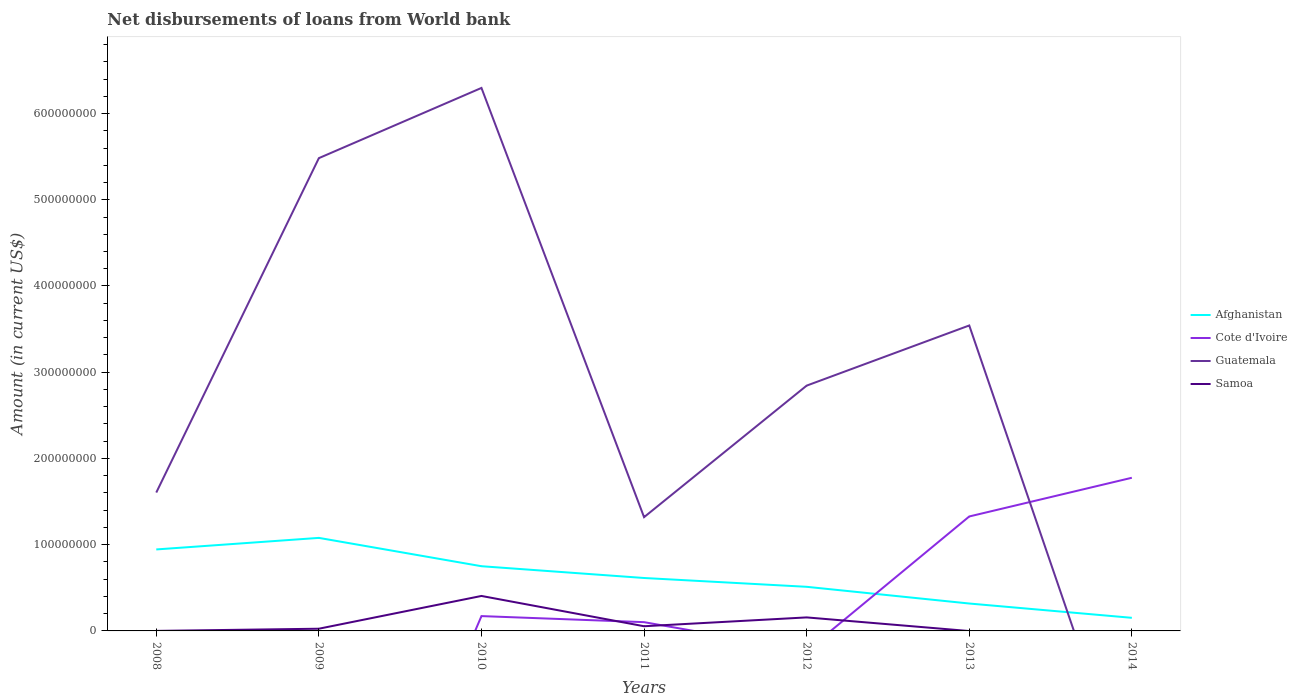How many different coloured lines are there?
Your answer should be very brief. 4. Is the number of lines equal to the number of legend labels?
Ensure brevity in your answer.  No. What is the total amount of loan disbursed from World Bank in Guatemala in the graph?
Offer a very short reply. 3.45e+08. What is the difference between the highest and the second highest amount of loan disbursed from World Bank in Afghanistan?
Your answer should be compact. 9.27e+07. What is the difference between the highest and the lowest amount of loan disbursed from World Bank in Afghanistan?
Provide a succinct answer. 3. What is the difference between two consecutive major ticks on the Y-axis?
Make the answer very short. 1.00e+08. Where does the legend appear in the graph?
Your response must be concise. Center right. How many legend labels are there?
Give a very brief answer. 4. How are the legend labels stacked?
Offer a very short reply. Vertical. What is the title of the graph?
Make the answer very short. Net disbursements of loans from World bank. What is the label or title of the X-axis?
Ensure brevity in your answer.  Years. What is the label or title of the Y-axis?
Offer a very short reply. Amount (in current US$). What is the Amount (in current US$) in Afghanistan in 2008?
Ensure brevity in your answer.  9.45e+07. What is the Amount (in current US$) of Cote d'Ivoire in 2008?
Your answer should be very brief. 0. What is the Amount (in current US$) in Guatemala in 2008?
Provide a succinct answer. 1.60e+08. What is the Amount (in current US$) in Samoa in 2008?
Keep it short and to the point. 3.60e+04. What is the Amount (in current US$) of Afghanistan in 2009?
Provide a short and direct response. 1.08e+08. What is the Amount (in current US$) of Cote d'Ivoire in 2009?
Give a very brief answer. 0. What is the Amount (in current US$) in Guatemala in 2009?
Provide a succinct answer. 5.48e+08. What is the Amount (in current US$) of Samoa in 2009?
Offer a terse response. 2.56e+06. What is the Amount (in current US$) of Afghanistan in 2010?
Your answer should be very brief. 7.50e+07. What is the Amount (in current US$) in Cote d'Ivoire in 2010?
Your answer should be compact. 1.72e+07. What is the Amount (in current US$) in Guatemala in 2010?
Offer a terse response. 6.30e+08. What is the Amount (in current US$) in Samoa in 2010?
Your answer should be compact. 4.05e+07. What is the Amount (in current US$) of Afghanistan in 2011?
Make the answer very short. 6.14e+07. What is the Amount (in current US$) in Cote d'Ivoire in 2011?
Your answer should be compact. 1.02e+07. What is the Amount (in current US$) in Guatemala in 2011?
Ensure brevity in your answer.  1.32e+08. What is the Amount (in current US$) in Samoa in 2011?
Provide a short and direct response. 5.44e+06. What is the Amount (in current US$) of Afghanistan in 2012?
Your answer should be compact. 5.12e+07. What is the Amount (in current US$) of Cote d'Ivoire in 2012?
Ensure brevity in your answer.  0. What is the Amount (in current US$) of Guatemala in 2012?
Your response must be concise. 2.84e+08. What is the Amount (in current US$) in Samoa in 2012?
Offer a very short reply. 1.57e+07. What is the Amount (in current US$) in Afghanistan in 2013?
Provide a short and direct response. 3.18e+07. What is the Amount (in current US$) in Cote d'Ivoire in 2013?
Provide a succinct answer. 1.33e+08. What is the Amount (in current US$) in Guatemala in 2013?
Your answer should be compact. 3.54e+08. What is the Amount (in current US$) in Afghanistan in 2014?
Offer a terse response. 1.52e+07. What is the Amount (in current US$) of Cote d'Ivoire in 2014?
Give a very brief answer. 1.78e+08. What is the Amount (in current US$) of Guatemala in 2014?
Your answer should be compact. 0. Across all years, what is the maximum Amount (in current US$) of Afghanistan?
Your response must be concise. 1.08e+08. Across all years, what is the maximum Amount (in current US$) of Cote d'Ivoire?
Offer a terse response. 1.78e+08. Across all years, what is the maximum Amount (in current US$) of Guatemala?
Provide a succinct answer. 6.30e+08. Across all years, what is the maximum Amount (in current US$) of Samoa?
Provide a succinct answer. 4.05e+07. Across all years, what is the minimum Amount (in current US$) of Afghanistan?
Provide a short and direct response. 1.52e+07. Across all years, what is the minimum Amount (in current US$) of Cote d'Ivoire?
Your answer should be very brief. 0. Across all years, what is the minimum Amount (in current US$) in Guatemala?
Make the answer very short. 0. What is the total Amount (in current US$) in Afghanistan in the graph?
Ensure brevity in your answer.  4.37e+08. What is the total Amount (in current US$) in Cote d'Ivoire in the graph?
Offer a terse response. 3.38e+08. What is the total Amount (in current US$) of Guatemala in the graph?
Offer a terse response. 2.11e+09. What is the total Amount (in current US$) in Samoa in the graph?
Provide a short and direct response. 6.43e+07. What is the difference between the Amount (in current US$) in Afghanistan in 2008 and that in 2009?
Provide a short and direct response. -1.34e+07. What is the difference between the Amount (in current US$) of Guatemala in 2008 and that in 2009?
Keep it short and to the point. -3.88e+08. What is the difference between the Amount (in current US$) of Samoa in 2008 and that in 2009?
Provide a short and direct response. -2.52e+06. What is the difference between the Amount (in current US$) of Afghanistan in 2008 and that in 2010?
Your answer should be very brief. 1.95e+07. What is the difference between the Amount (in current US$) of Guatemala in 2008 and that in 2010?
Provide a short and direct response. -4.69e+08. What is the difference between the Amount (in current US$) in Samoa in 2008 and that in 2010?
Your answer should be very brief. -4.05e+07. What is the difference between the Amount (in current US$) of Afghanistan in 2008 and that in 2011?
Offer a very short reply. 3.31e+07. What is the difference between the Amount (in current US$) of Guatemala in 2008 and that in 2011?
Provide a short and direct response. 2.85e+07. What is the difference between the Amount (in current US$) in Samoa in 2008 and that in 2011?
Your response must be concise. -5.40e+06. What is the difference between the Amount (in current US$) in Afghanistan in 2008 and that in 2012?
Provide a succinct answer. 4.33e+07. What is the difference between the Amount (in current US$) in Guatemala in 2008 and that in 2012?
Provide a succinct answer. -1.24e+08. What is the difference between the Amount (in current US$) of Samoa in 2008 and that in 2012?
Offer a very short reply. -1.56e+07. What is the difference between the Amount (in current US$) in Afghanistan in 2008 and that in 2013?
Give a very brief answer. 6.27e+07. What is the difference between the Amount (in current US$) of Guatemala in 2008 and that in 2013?
Keep it short and to the point. -1.94e+08. What is the difference between the Amount (in current US$) of Afghanistan in 2008 and that in 2014?
Ensure brevity in your answer.  7.93e+07. What is the difference between the Amount (in current US$) in Afghanistan in 2009 and that in 2010?
Your answer should be very brief. 3.29e+07. What is the difference between the Amount (in current US$) in Guatemala in 2009 and that in 2010?
Provide a succinct answer. -8.14e+07. What is the difference between the Amount (in current US$) in Samoa in 2009 and that in 2010?
Make the answer very short. -3.80e+07. What is the difference between the Amount (in current US$) of Afghanistan in 2009 and that in 2011?
Give a very brief answer. 4.65e+07. What is the difference between the Amount (in current US$) in Guatemala in 2009 and that in 2011?
Your answer should be compact. 4.16e+08. What is the difference between the Amount (in current US$) in Samoa in 2009 and that in 2011?
Give a very brief answer. -2.88e+06. What is the difference between the Amount (in current US$) in Afghanistan in 2009 and that in 2012?
Provide a short and direct response. 5.67e+07. What is the difference between the Amount (in current US$) in Guatemala in 2009 and that in 2012?
Provide a short and direct response. 2.64e+08. What is the difference between the Amount (in current US$) of Samoa in 2009 and that in 2012?
Your answer should be very brief. -1.31e+07. What is the difference between the Amount (in current US$) of Afghanistan in 2009 and that in 2013?
Give a very brief answer. 7.61e+07. What is the difference between the Amount (in current US$) in Guatemala in 2009 and that in 2013?
Ensure brevity in your answer.  1.94e+08. What is the difference between the Amount (in current US$) of Afghanistan in 2009 and that in 2014?
Your response must be concise. 9.27e+07. What is the difference between the Amount (in current US$) of Afghanistan in 2010 and that in 2011?
Ensure brevity in your answer.  1.37e+07. What is the difference between the Amount (in current US$) in Cote d'Ivoire in 2010 and that in 2011?
Your answer should be very brief. 7.03e+06. What is the difference between the Amount (in current US$) in Guatemala in 2010 and that in 2011?
Keep it short and to the point. 4.98e+08. What is the difference between the Amount (in current US$) in Samoa in 2010 and that in 2011?
Provide a short and direct response. 3.51e+07. What is the difference between the Amount (in current US$) of Afghanistan in 2010 and that in 2012?
Provide a short and direct response. 2.39e+07. What is the difference between the Amount (in current US$) of Guatemala in 2010 and that in 2012?
Your answer should be compact. 3.45e+08. What is the difference between the Amount (in current US$) in Samoa in 2010 and that in 2012?
Your answer should be compact. 2.49e+07. What is the difference between the Amount (in current US$) of Afghanistan in 2010 and that in 2013?
Make the answer very short. 4.33e+07. What is the difference between the Amount (in current US$) in Cote d'Ivoire in 2010 and that in 2013?
Ensure brevity in your answer.  -1.16e+08. What is the difference between the Amount (in current US$) of Guatemala in 2010 and that in 2013?
Your response must be concise. 2.75e+08. What is the difference between the Amount (in current US$) in Afghanistan in 2010 and that in 2014?
Your answer should be compact. 5.98e+07. What is the difference between the Amount (in current US$) in Cote d'Ivoire in 2010 and that in 2014?
Provide a succinct answer. -1.60e+08. What is the difference between the Amount (in current US$) of Afghanistan in 2011 and that in 2012?
Offer a terse response. 1.02e+07. What is the difference between the Amount (in current US$) in Guatemala in 2011 and that in 2012?
Make the answer very short. -1.53e+08. What is the difference between the Amount (in current US$) in Samoa in 2011 and that in 2012?
Your answer should be very brief. -1.02e+07. What is the difference between the Amount (in current US$) in Afghanistan in 2011 and that in 2013?
Ensure brevity in your answer.  2.96e+07. What is the difference between the Amount (in current US$) of Cote d'Ivoire in 2011 and that in 2013?
Your answer should be compact. -1.23e+08. What is the difference between the Amount (in current US$) in Guatemala in 2011 and that in 2013?
Make the answer very short. -2.22e+08. What is the difference between the Amount (in current US$) of Afghanistan in 2011 and that in 2014?
Your answer should be very brief. 4.62e+07. What is the difference between the Amount (in current US$) in Cote d'Ivoire in 2011 and that in 2014?
Give a very brief answer. -1.67e+08. What is the difference between the Amount (in current US$) of Afghanistan in 2012 and that in 2013?
Your answer should be very brief. 1.94e+07. What is the difference between the Amount (in current US$) of Guatemala in 2012 and that in 2013?
Offer a terse response. -6.98e+07. What is the difference between the Amount (in current US$) of Afghanistan in 2012 and that in 2014?
Ensure brevity in your answer.  3.60e+07. What is the difference between the Amount (in current US$) of Afghanistan in 2013 and that in 2014?
Give a very brief answer. 1.66e+07. What is the difference between the Amount (in current US$) in Cote d'Ivoire in 2013 and that in 2014?
Your answer should be very brief. -4.49e+07. What is the difference between the Amount (in current US$) of Afghanistan in 2008 and the Amount (in current US$) of Guatemala in 2009?
Your response must be concise. -4.54e+08. What is the difference between the Amount (in current US$) in Afghanistan in 2008 and the Amount (in current US$) in Samoa in 2009?
Offer a terse response. 9.19e+07. What is the difference between the Amount (in current US$) of Guatemala in 2008 and the Amount (in current US$) of Samoa in 2009?
Provide a succinct answer. 1.58e+08. What is the difference between the Amount (in current US$) of Afghanistan in 2008 and the Amount (in current US$) of Cote d'Ivoire in 2010?
Keep it short and to the point. 7.73e+07. What is the difference between the Amount (in current US$) of Afghanistan in 2008 and the Amount (in current US$) of Guatemala in 2010?
Offer a very short reply. -5.35e+08. What is the difference between the Amount (in current US$) of Afghanistan in 2008 and the Amount (in current US$) of Samoa in 2010?
Provide a succinct answer. 5.40e+07. What is the difference between the Amount (in current US$) of Guatemala in 2008 and the Amount (in current US$) of Samoa in 2010?
Keep it short and to the point. 1.20e+08. What is the difference between the Amount (in current US$) of Afghanistan in 2008 and the Amount (in current US$) of Cote d'Ivoire in 2011?
Your response must be concise. 8.43e+07. What is the difference between the Amount (in current US$) in Afghanistan in 2008 and the Amount (in current US$) in Guatemala in 2011?
Your answer should be very brief. -3.74e+07. What is the difference between the Amount (in current US$) in Afghanistan in 2008 and the Amount (in current US$) in Samoa in 2011?
Keep it short and to the point. 8.91e+07. What is the difference between the Amount (in current US$) of Guatemala in 2008 and the Amount (in current US$) of Samoa in 2011?
Your answer should be compact. 1.55e+08. What is the difference between the Amount (in current US$) of Afghanistan in 2008 and the Amount (in current US$) of Guatemala in 2012?
Your answer should be compact. -1.90e+08. What is the difference between the Amount (in current US$) in Afghanistan in 2008 and the Amount (in current US$) in Samoa in 2012?
Ensure brevity in your answer.  7.88e+07. What is the difference between the Amount (in current US$) of Guatemala in 2008 and the Amount (in current US$) of Samoa in 2012?
Provide a short and direct response. 1.45e+08. What is the difference between the Amount (in current US$) of Afghanistan in 2008 and the Amount (in current US$) of Cote d'Ivoire in 2013?
Provide a short and direct response. -3.82e+07. What is the difference between the Amount (in current US$) of Afghanistan in 2008 and the Amount (in current US$) of Guatemala in 2013?
Give a very brief answer. -2.60e+08. What is the difference between the Amount (in current US$) of Afghanistan in 2008 and the Amount (in current US$) of Cote d'Ivoire in 2014?
Ensure brevity in your answer.  -8.31e+07. What is the difference between the Amount (in current US$) of Afghanistan in 2009 and the Amount (in current US$) of Cote d'Ivoire in 2010?
Your answer should be very brief. 9.07e+07. What is the difference between the Amount (in current US$) of Afghanistan in 2009 and the Amount (in current US$) of Guatemala in 2010?
Give a very brief answer. -5.22e+08. What is the difference between the Amount (in current US$) in Afghanistan in 2009 and the Amount (in current US$) in Samoa in 2010?
Offer a very short reply. 6.73e+07. What is the difference between the Amount (in current US$) of Guatemala in 2009 and the Amount (in current US$) of Samoa in 2010?
Your answer should be compact. 5.08e+08. What is the difference between the Amount (in current US$) in Afghanistan in 2009 and the Amount (in current US$) in Cote d'Ivoire in 2011?
Give a very brief answer. 9.77e+07. What is the difference between the Amount (in current US$) in Afghanistan in 2009 and the Amount (in current US$) in Guatemala in 2011?
Make the answer very short. -2.40e+07. What is the difference between the Amount (in current US$) of Afghanistan in 2009 and the Amount (in current US$) of Samoa in 2011?
Your response must be concise. 1.02e+08. What is the difference between the Amount (in current US$) of Guatemala in 2009 and the Amount (in current US$) of Samoa in 2011?
Offer a very short reply. 5.43e+08. What is the difference between the Amount (in current US$) in Afghanistan in 2009 and the Amount (in current US$) in Guatemala in 2012?
Your answer should be very brief. -1.77e+08. What is the difference between the Amount (in current US$) in Afghanistan in 2009 and the Amount (in current US$) in Samoa in 2012?
Your answer should be very brief. 9.22e+07. What is the difference between the Amount (in current US$) in Guatemala in 2009 and the Amount (in current US$) in Samoa in 2012?
Your answer should be compact. 5.33e+08. What is the difference between the Amount (in current US$) of Afghanistan in 2009 and the Amount (in current US$) of Cote d'Ivoire in 2013?
Give a very brief answer. -2.48e+07. What is the difference between the Amount (in current US$) of Afghanistan in 2009 and the Amount (in current US$) of Guatemala in 2013?
Provide a succinct answer. -2.46e+08. What is the difference between the Amount (in current US$) in Afghanistan in 2009 and the Amount (in current US$) in Cote d'Ivoire in 2014?
Your answer should be very brief. -6.97e+07. What is the difference between the Amount (in current US$) in Afghanistan in 2010 and the Amount (in current US$) in Cote d'Ivoire in 2011?
Make the answer very short. 6.49e+07. What is the difference between the Amount (in current US$) of Afghanistan in 2010 and the Amount (in current US$) of Guatemala in 2011?
Provide a short and direct response. -5.69e+07. What is the difference between the Amount (in current US$) in Afghanistan in 2010 and the Amount (in current US$) in Samoa in 2011?
Give a very brief answer. 6.96e+07. What is the difference between the Amount (in current US$) in Cote d'Ivoire in 2010 and the Amount (in current US$) in Guatemala in 2011?
Keep it short and to the point. -1.15e+08. What is the difference between the Amount (in current US$) in Cote d'Ivoire in 2010 and the Amount (in current US$) in Samoa in 2011?
Give a very brief answer. 1.18e+07. What is the difference between the Amount (in current US$) in Guatemala in 2010 and the Amount (in current US$) in Samoa in 2011?
Give a very brief answer. 6.24e+08. What is the difference between the Amount (in current US$) of Afghanistan in 2010 and the Amount (in current US$) of Guatemala in 2012?
Offer a terse response. -2.09e+08. What is the difference between the Amount (in current US$) of Afghanistan in 2010 and the Amount (in current US$) of Samoa in 2012?
Give a very brief answer. 5.94e+07. What is the difference between the Amount (in current US$) of Cote d'Ivoire in 2010 and the Amount (in current US$) of Guatemala in 2012?
Make the answer very short. -2.67e+08. What is the difference between the Amount (in current US$) in Cote d'Ivoire in 2010 and the Amount (in current US$) in Samoa in 2012?
Provide a short and direct response. 1.53e+06. What is the difference between the Amount (in current US$) in Guatemala in 2010 and the Amount (in current US$) in Samoa in 2012?
Provide a short and direct response. 6.14e+08. What is the difference between the Amount (in current US$) in Afghanistan in 2010 and the Amount (in current US$) in Cote d'Ivoire in 2013?
Offer a terse response. -5.77e+07. What is the difference between the Amount (in current US$) of Afghanistan in 2010 and the Amount (in current US$) of Guatemala in 2013?
Provide a succinct answer. -2.79e+08. What is the difference between the Amount (in current US$) in Cote d'Ivoire in 2010 and the Amount (in current US$) in Guatemala in 2013?
Your answer should be compact. -3.37e+08. What is the difference between the Amount (in current US$) in Afghanistan in 2010 and the Amount (in current US$) in Cote d'Ivoire in 2014?
Your response must be concise. -1.03e+08. What is the difference between the Amount (in current US$) in Afghanistan in 2011 and the Amount (in current US$) in Guatemala in 2012?
Offer a very short reply. -2.23e+08. What is the difference between the Amount (in current US$) of Afghanistan in 2011 and the Amount (in current US$) of Samoa in 2012?
Offer a very short reply. 4.57e+07. What is the difference between the Amount (in current US$) in Cote d'Ivoire in 2011 and the Amount (in current US$) in Guatemala in 2012?
Give a very brief answer. -2.74e+08. What is the difference between the Amount (in current US$) of Cote d'Ivoire in 2011 and the Amount (in current US$) of Samoa in 2012?
Ensure brevity in your answer.  -5.50e+06. What is the difference between the Amount (in current US$) of Guatemala in 2011 and the Amount (in current US$) of Samoa in 2012?
Your response must be concise. 1.16e+08. What is the difference between the Amount (in current US$) of Afghanistan in 2011 and the Amount (in current US$) of Cote d'Ivoire in 2013?
Give a very brief answer. -7.14e+07. What is the difference between the Amount (in current US$) of Afghanistan in 2011 and the Amount (in current US$) of Guatemala in 2013?
Provide a short and direct response. -2.93e+08. What is the difference between the Amount (in current US$) in Cote d'Ivoire in 2011 and the Amount (in current US$) in Guatemala in 2013?
Provide a short and direct response. -3.44e+08. What is the difference between the Amount (in current US$) in Afghanistan in 2011 and the Amount (in current US$) in Cote d'Ivoire in 2014?
Keep it short and to the point. -1.16e+08. What is the difference between the Amount (in current US$) of Afghanistan in 2012 and the Amount (in current US$) of Cote d'Ivoire in 2013?
Offer a terse response. -8.16e+07. What is the difference between the Amount (in current US$) of Afghanistan in 2012 and the Amount (in current US$) of Guatemala in 2013?
Provide a short and direct response. -3.03e+08. What is the difference between the Amount (in current US$) of Afghanistan in 2012 and the Amount (in current US$) of Cote d'Ivoire in 2014?
Offer a very short reply. -1.26e+08. What is the difference between the Amount (in current US$) in Afghanistan in 2013 and the Amount (in current US$) in Cote d'Ivoire in 2014?
Ensure brevity in your answer.  -1.46e+08. What is the average Amount (in current US$) in Afghanistan per year?
Ensure brevity in your answer.  6.24e+07. What is the average Amount (in current US$) in Cote d'Ivoire per year?
Your response must be concise. 4.82e+07. What is the average Amount (in current US$) in Guatemala per year?
Make the answer very short. 3.01e+08. What is the average Amount (in current US$) of Samoa per year?
Keep it short and to the point. 9.18e+06. In the year 2008, what is the difference between the Amount (in current US$) in Afghanistan and Amount (in current US$) in Guatemala?
Give a very brief answer. -6.60e+07. In the year 2008, what is the difference between the Amount (in current US$) in Afghanistan and Amount (in current US$) in Samoa?
Offer a terse response. 9.45e+07. In the year 2008, what is the difference between the Amount (in current US$) of Guatemala and Amount (in current US$) of Samoa?
Your response must be concise. 1.60e+08. In the year 2009, what is the difference between the Amount (in current US$) in Afghanistan and Amount (in current US$) in Guatemala?
Provide a succinct answer. -4.40e+08. In the year 2009, what is the difference between the Amount (in current US$) of Afghanistan and Amount (in current US$) of Samoa?
Your answer should be compact. 1.05e+08. In the year 2009, what is the difference between the Amount (in current US$) of Guatemala and Amount (in current US$) of Samoa?
Offer a very short reply. 5.46e+08. In the year 2010, what is the difference between the Amount (in current US$) of Afghanistan and Amount (in current US$) of Cote d'Ivoire?
Offer a very short reply. 5.78e+07. In the year 2010, what is the difference between the Amount (in current US$) in Afghanistan and Amount (in current US$) in Guatemala?
Make the answer very short. -5.55e+08. In the year 2010, what is the difference between the Amount (in current US$) in Afghanistan and Amount (in current US$) in Samoa?
Keep it short and to the point. 3.45e+07. In the year 2010, what is the difference between the Amount (in current US$) in Cote d'Ivoire and Amount (in current US$) in Guatemala?
Offer a terse response. -6.12e+08. In the year 2010, what is the difference between the Amount (in current US$) of Cote d'Ivoire and Amount (in current US$) of Samoa?
Your answer should be compact. -2.33e+07. In the year 2010, what is the difference between the Amount (in current US$) of Guatemala and Amount (in current US$) of Samoa?
Your answer should be compact. 5.89e+08. In the year 2011, what is the difference between the Amount (in current US$) of Afghanistan and Amount (in current US$) of Cote d'Ivoire?
Offer a very short reply. 5.12e+07. In the year 2011, what is the difference between the Amount (in current US$) of Afghanistan and Amount (in current US$) of Guatemala?
Make the answer very short. -7.05e+07. In the year 2011, what is the difference between the Amount (in current US$) in Afghanistan and Amount (in current US$) in Samoa?
Your answer should be compact. 5.59e+07. In the year 2011, what is the difference between the Amount (in current US$) of Cote d'Ivoire and Amount (in current US$) of Guatemala?
Your response must be concise. -1.22e+08. In the year 2011, what is the difference between the Amount (in current US$) in Cote d'Ivoire and Amount (in current US$) in Samoa?
Give a very brief answer. 4.73e+06. In the year 2011, what is the difference between the Amount (in current US$) in Guatemala and Amount (in current US$) in Samoa?
Ensure brevity in your answer.  1.26e+08. In the year 2012, what is the difference between the Amount (in current US$) of Afghanistan and Amount (in current US$) of Guatemala?
Give a very brief answer. -2.33e+08. In the year 2012, what is the difference between the Amount (in current US$) of Afghanistan and Amount (in current US$) of Samoa?
Give a very brief answer. 3.55e+07. In the year 2012, what is the difference between the Amount (in current US$) in Guatemala and Amount (in current US$) in Samoa?
Provide a short and direct response. 2.69e+08. In the year 2013, what is the difference between the Amount (in current US$) in Afghanistan and Amount (in current US$) in Cote d'Ivoire?
Keep it short and to the point. -1.01e+08. In the year 2013, what is the difference between the Amount (in current US$) of Afghanistan and Amount (in current US$) of Guatemala?
Offer a terse response. -3.22e+08. In the year 2013, what is the difference between the Amount (in current US$) of Cote d'Ivoire and Amount (in current US$) of Guatemala?
Give a very brief answer. -2.21e+08. In the year 2014, what is the difference between the Amount (in current US$) in Afghanistan and Amount (in current US$) in Cote d'Ivoire?
Offer a terse response. -1.62e+08. What is the ratio of the Amount (in current US$) in Afghanistan in 2008 to that in 2009?
Provide a succinct answer. 0.88. What is the ratio of the Amount (in current US$) in Guatemala in 2008 to that in 2009?
Make the answer very short. 0.29. What is the ratio of the Amount (in current US$) of Samoa in 2008 to that in 2009?
Provide a short and direct response. 0.01. What is the ratio of the Amount (in current US$) in Afghanistan in 2008 to that in 2010?
Keep it short and to the point. 1.26. What is the ratio of the Amount (in current US$) of Guatemala in 2008 to that in 2010?
Offer a terse response. 0.25. What is the ratio of the Amount (in current US$) in Samoa in 2008 to that in 2010?
Your answer should be very brief. 0. What is the ratio of the Amount (in current US$) of Afghanistan in 2008 to that in 2011?
Your answer should be compact. 1.54. What is the ratio of the Amount (in current US$) in Guatemala in 2008 to that in 2011?
Ensure brevity in your answer.  1.22. What is the ratio of the Amount (in current US$) of Samoa in 2008 to that in 2011?
Your answer should be very brief. 0.01. What is the ratio of the Amount (in current US$) of Afghanistan in 2008 to that in 2012?
Keep it short and to the point. 1.85. What is the ratio of the Amount (in current US$) in Guatemala in 2008 to that in 2012?
Your answer should be very brief. 0.56. What is the ratio of the Amount (in current US$) in Samoa in 2008 to that in 2012?
Provide a short and direct response. 0. What is the ratio of the Amount (in current US$) in Afghanistan in 2008 to that in 2013?
Offer a very short reply. 2.97. What is the ratio of the Amount (in current US$) of Guatemala in 2008 to that in 2013?
Offer a very short reply. 0.45. What is the ratio of the Amount (in current US$) in Afghanistan in 2008 to that in 2014?
Your answer should be very brief. 6.22. What is the ratio of the Amount (in current US$) of Afghanistan in 2009 to that in 2010?
Your answer should be compact. 1.44. What is the ratio of the Amount (in current US$) of Guatemala in 2009 to that in 2010?
Offer a very short reply. 0.87. What is the ratio of the Amount (in current US$) in Samoa in 2009 to that in 2010?
Give a very brief answer. 0.06. What is the ratio of the Amount (in current US$) in Afghanistan in 2009 to that in 2011?
Keep it short and to the point. 1.76. What is the ratio of the Amount (in current US$) in Guatemala in 2009 to that in 2011?
Make the answer very short. 4.16. What is the ratio of the Amount (in current US$) of Samoa in 2009 to that in 2011?
Ensure brevity in your answer.  0.47. What is the ratio of the Amount (in current US$) in Afghanistan in 2009 to that in 2012?
Ensure brevity in your answer.  2.11. What is the ratio of the Amount (in current US$) in Guatemala in 2009 to that in 2012?
Give a very brief answer. 1.93. What is the ratio of the Amount (in current US$) in Samoa in 2009 to that in 2012?
Your response must be concise. 0.16. What is the ratio of the Amount (in current US$) of Afghanistan in 2009 to that in 2013?
Keep it short and to the point. 3.39. What is the ratio of the Amount (in current US$) in Guatemala in 2009 to that in 2013?
Your response must be concise. 1.55. What is the ratio of the Amount (in current US$) of Afghanistan in 2009 to that in 2014?
Your answer should be compact. 7.1. What is the ratio of the Amount (in current US$) in Afghanistan in 2010 to that in 2011?
Provide a short and direct response. 1.22. What is the ratio of the Amount (in current US$) in Cote d'Ivoire in 2010 to that in 2011?
Provide a short and direct response. 1.69. What is the ratio of the Amount (in current US$) in Guatemala in 2010 to that in 2011?
Provide a short and direct response. 4.77. What is the ratio of the Amount (in current US$) of Samoa in 2010 to that in 2011?
Offer a terse response. 7.45. What is the ratio of the Amount (in current US$) in Afghanistan in 2010 to that in 2012?
Provide a succinct answer. 1.47. What is the ratio of the Amount (in current US$) of Guatemala in 2010 to that in 2012?
Offer a very short reply. 2.21. What is the ratio of the Amount (in current US$) in Samoa in 2010 to that in 2012?
Provide a short and direct response. 2.59. What is the ratio of the Amount (in current US$) of Afghanistan in 2010 to that in 2013?
Give a very brief answer. 2.36. What is the ratio of the Amount (in current US$) in Cote d'Ivoire in 2010 to that in 2013?
Make the answer very short. 0.13. What is the ratio of the Amount (in current US$) of Guatemala in 2010 to that in 2013?
Offer a terse response. 1.78. What is the ratio of the Amount (in current US$) in Afghanistan in 2010 to that in 2014?
Offer a very short reply. 4.94. What is the ratio of the Amount (in current US$) of Cote d'Ivoire in 2010 to that in 2014?
Keep it short and to the point. 0.1. What is the ratio of the Amount (in current US$) of Afghanistan in 2011 to that in 2012?
Give a very brief answer. 1.2. What is the ratio of the Amount (in current US$) in Guatemala in 2011 to that in 2012?
Keep it short and to the point. 0.46. What is the ratio of the Amount (in current US$) in Samoa in 2011 to that in 2012?
Keep it short and to the point. 0.35. What is the ratio of the Amount (in current US$) in Afghanistan in 2011 to that in 2013?
Offer a very short reply. 1.93. What is the ratio of the Amount (in current US$) in Cote d'Ivoire in 2011 to that in 2013?
Ensure brevity in your answer.  0.08. What is the ratio of the Amount (in current US$) in Guatemala in 2011 to that in 2013?
Provide a succinct answer. 0.37. What is the ratio of the Amount (in current US$) in Afghanistan in 2011 to that in 2014?
Provide a succinct answer. 4.04. What is the ratio of the Amount (in current US$) of Cote d'Ivoire in 2011 to that in 2014?
Offer a terse response. 0.06. What is the ratio of the Amount (in current US$) of Afghanistan in 2012 to that in 2013?
Keep it short and to the point. 1.61. What is the ratio of the Amount (in current US$) in Guatemala in 2012 to that in 2013?
Make the answer very short. 0.8. What is the ratio of the Amount (in current US$) of Afghanistan in 2012 to that in 2014?
Provide a succinct answer. 3.37. What is the ratio of the Amount (in current US$) of Afghanistan in 2013 to that in 2014?
Your answer should be compact. 2.09. What is the ratio of the Amount (in current US$) of Cote d'Ivoire in 2013 to that in 2014?
Offer a terse response. 0.75. What is the difference between the highest and the second highest Amount (in current US$) of Afghanistan?
Your answer should be compact. 1.34e+07. What is the difference between the highest and the second highest Amount (in current US$) of Cote d'Ivoire?
Make the answer very short. 4.49e+07. What is the difference between the highest and the second highest Amount (in current US$) of Guatemala?
Offer a very short reply. 8.14e+07. What is the difference between the highest and the second highest Amount (in current US$) in Samoa?
Offer a very short reply. 2.49e+07. What is the difference between the highest and the lowest Amount (in current US$) of Afghanistan?
Keep it short and to the point. 9.27e+07. What is the difference between the highest and the lowest Amount (in current US$) of Cote d'Ivoire?
Make the answer very short. 1.78e+08. What is the difference between the highest and the lowest Amount (in current US$) in Guatemala?
Your answer should be very brief. 6.30e+08. What is the difference between the highest and the lowest Amount (in current US$) of Samoa?
Ensure brevity in your answer.  4.05e+07. 